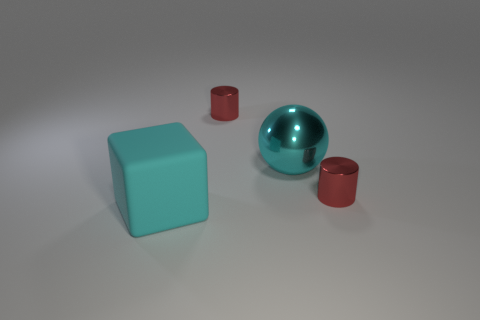What materials do the objects in the image seem to be made of? The objects in the image appear to have different materials. The cube looks to have a matte surface possibly resembling plastic, while the sphere and cylindrical objects both exhibit a metallic sheen, indicative of a reflective metal composition. 